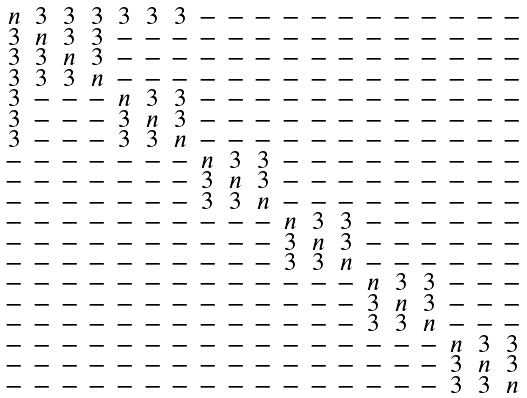Convert formula to latex. <formula><loc_0><loc_0><loc_500><loc_500>\begin{smallmatrix} n & 3 & 3 & 3 & 3 & 3 & 3 & - & - & - & - & - & - & - & - & - & - & - & - \\ 3 & n & 3 & 3 & - & - & - & - & - & - & - & - & - & - & - & - & - & - & - \\ 3 & 3 & n & 3 & - & - & - & - & - & - & - & - & - & - & - & - & - & - & - \\ 3 & 3 & 3 & n & - & - & - & - & - & - & - & - & - & - & - & - & - & - & - \\ 3 & - & - & - & n & 3 & 3 & - & - & - & - & - & - & - & - & - & - & - & - \\ 3 & - & - & - & 3 & n & 3 & - & - & - & - & - & - & - & - & - & - & - & - \\ 3 & - & - & - & 3 & 3 & n & - & - & - & - & - & - & - & - & - & - & - & - \\ - & - & - & - & - & - & - & n & 3 & 3 & - & - & - & - & - & - & - & - & - \\ - & - & - & - & - & - & - & 3 & n & 3 & - & - & - & - & - & - & - & - & - \\ - & - & - & - & - & - & - & 3 & 3 & n & - & - & - & - & - & - & - & - & - \\ - & - & - & - & - & - & - & - & - & - & n & 3 & 3 & - & - & - & - & - & - \\ - & - & - & - & - & - & - & - & - & - & 3 & n & 3 & - & - & - & - & - & - \\ - & - & - & - & - & - & - & - & - & - & 3 & 3 & n & - & - & - & - & - & - \\ - & - & - & - & - & - & - & - & - & - & - & - & - & n & 3 & 3 & - & - & - \\ - & - & - & - & - & - & - & - & - & - & - & - & - & 3 & n & 3 & - & - & - \\ - & - & - & - & - & - & - & - & - & - & - & - & - & 3 & 3 & n & - & - & - \\ - & - & - & - & - & - & - & - & - & - & - & - & - & - & - & - & n & 3 & 3 \\ - & - & - & - & - & - & - & - & - & - & - & - & - & - & - & - & 3 & n & 3 \\ - & - & - & - & - & - & - & - & - & - & - & - & - & - & - & - & 3 & 3 & n \\ \end{smallmatrix}</formula> 